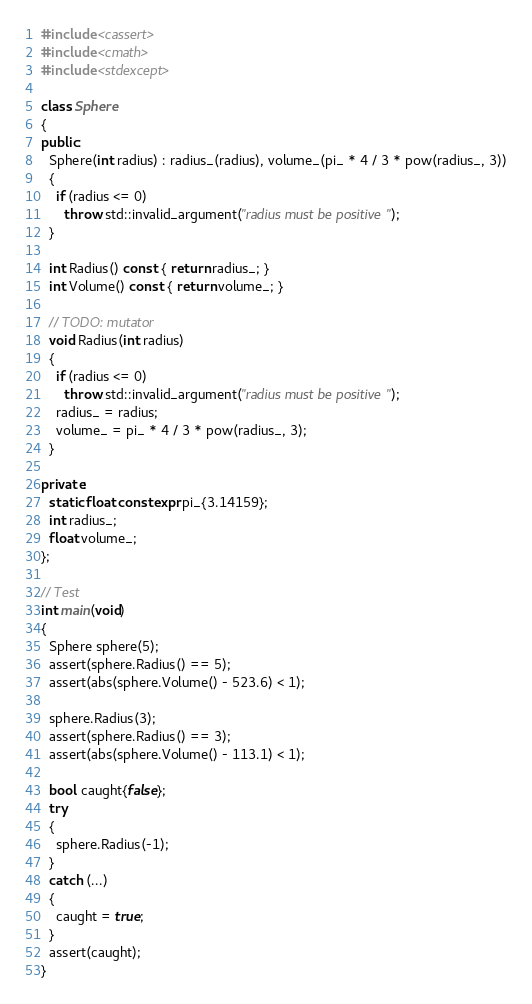<code> <loc_0><loc_0><loc_500><loc_500><_C++_>#include <cassert>
#include <cmath>
#include <stdexcept>

class Sphere
{
public:
  Sphere(int radius) : radius_(radius), volume_(pi_ * 4 / 3 * pow(radius_, 3))
  {
    if (radius <= 0)
      throw std::invalid_argument("radius must be positive");
  }

  int Radius() const { return radius_; }
  int Volume() const { return volume_; }

  // TODO: mutator
  void Radius(int radius)
  {
    if (radius <= 0)
      throw std::invalid_argument("radius must be positive");
    radius_ = radius;
    volume_ = pi_ * 4 / 3 * pow(radius_, 3);
  }

private:
  static float constexpr pi_{3.14159};
  int radius_;
  float volume_;
};

// Test
int main(void)
{
  Sphere sphere(5);
  assert(sphere.Radius() == 5);
  assert(abs(sphere.Volume() - 523.6) < 1);

  sphere.Radius(3);
  assert(sphere.Radius() == 3);
  assert(abs(sphere.Volume() - 113.1) < 1);

  bool caught{false};
  try
  {
    sphere.Radius(-1);
  }
  catch (...)
  {
    caught = true;
  }
  assert(caught);
}</code> 